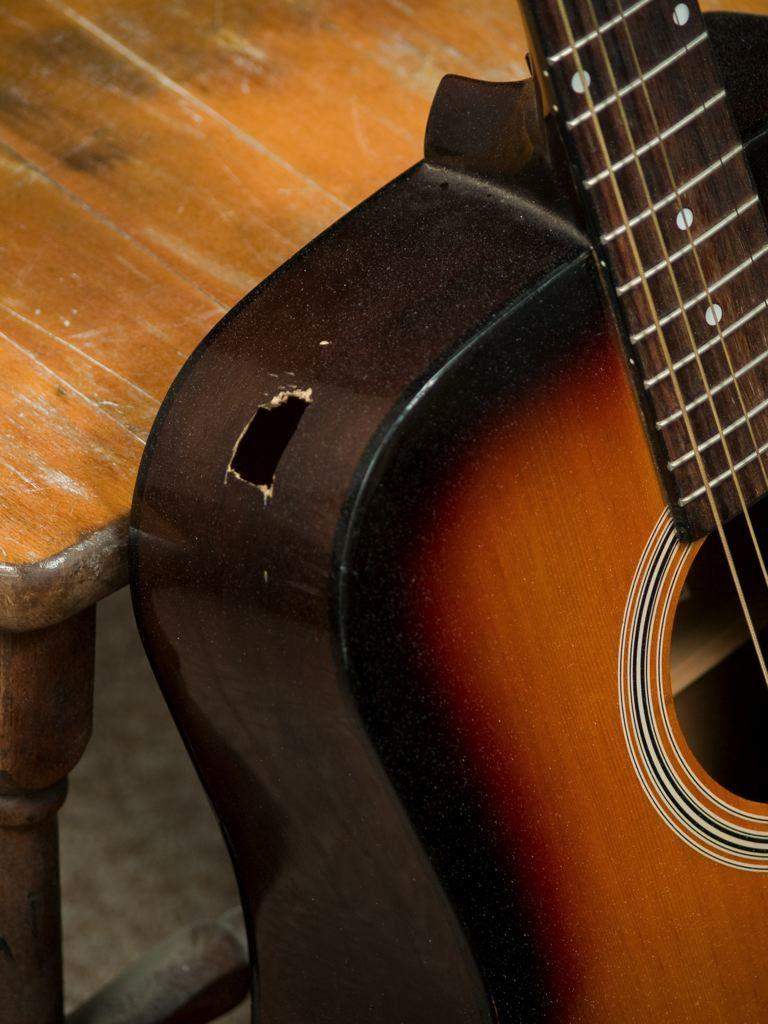What musical instrument is present in the image? There is a guitar in the image. What is the condition of the guitar? The guitar has a hole in it and has strings. Where is the guitar placed in relation to other objects? The guitar is placed beside a table. What colors can be seen on the guitar? The guitar is in brown and black color. How many pies are on the table next to the guitar in the image? There is no mention of pies in the image; the focus is on the guitar and its condition. 